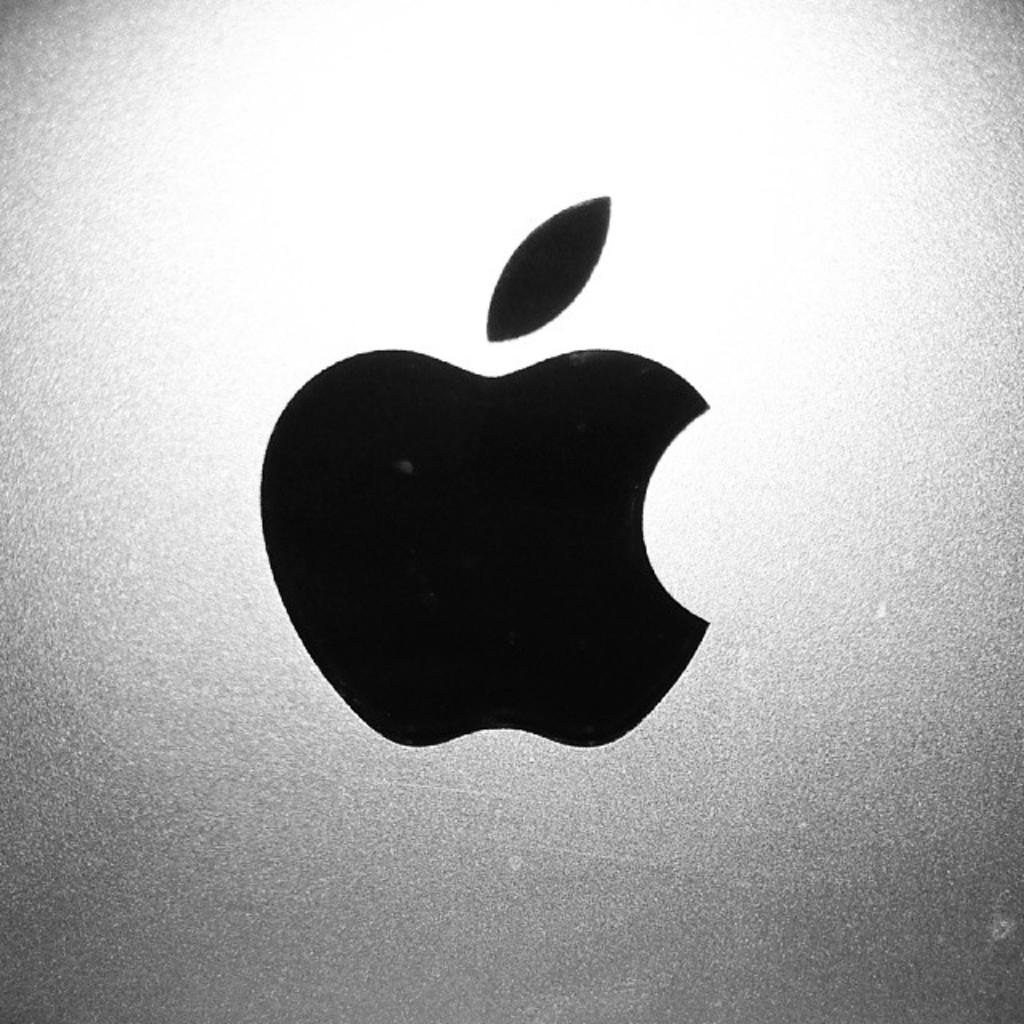What is the main feature of the image? There is a logo in the image. How does the fog affect the visibility of the logo in the image? There is no fog present in the image, so its effect on the visibility of the logo cannot be determined. 